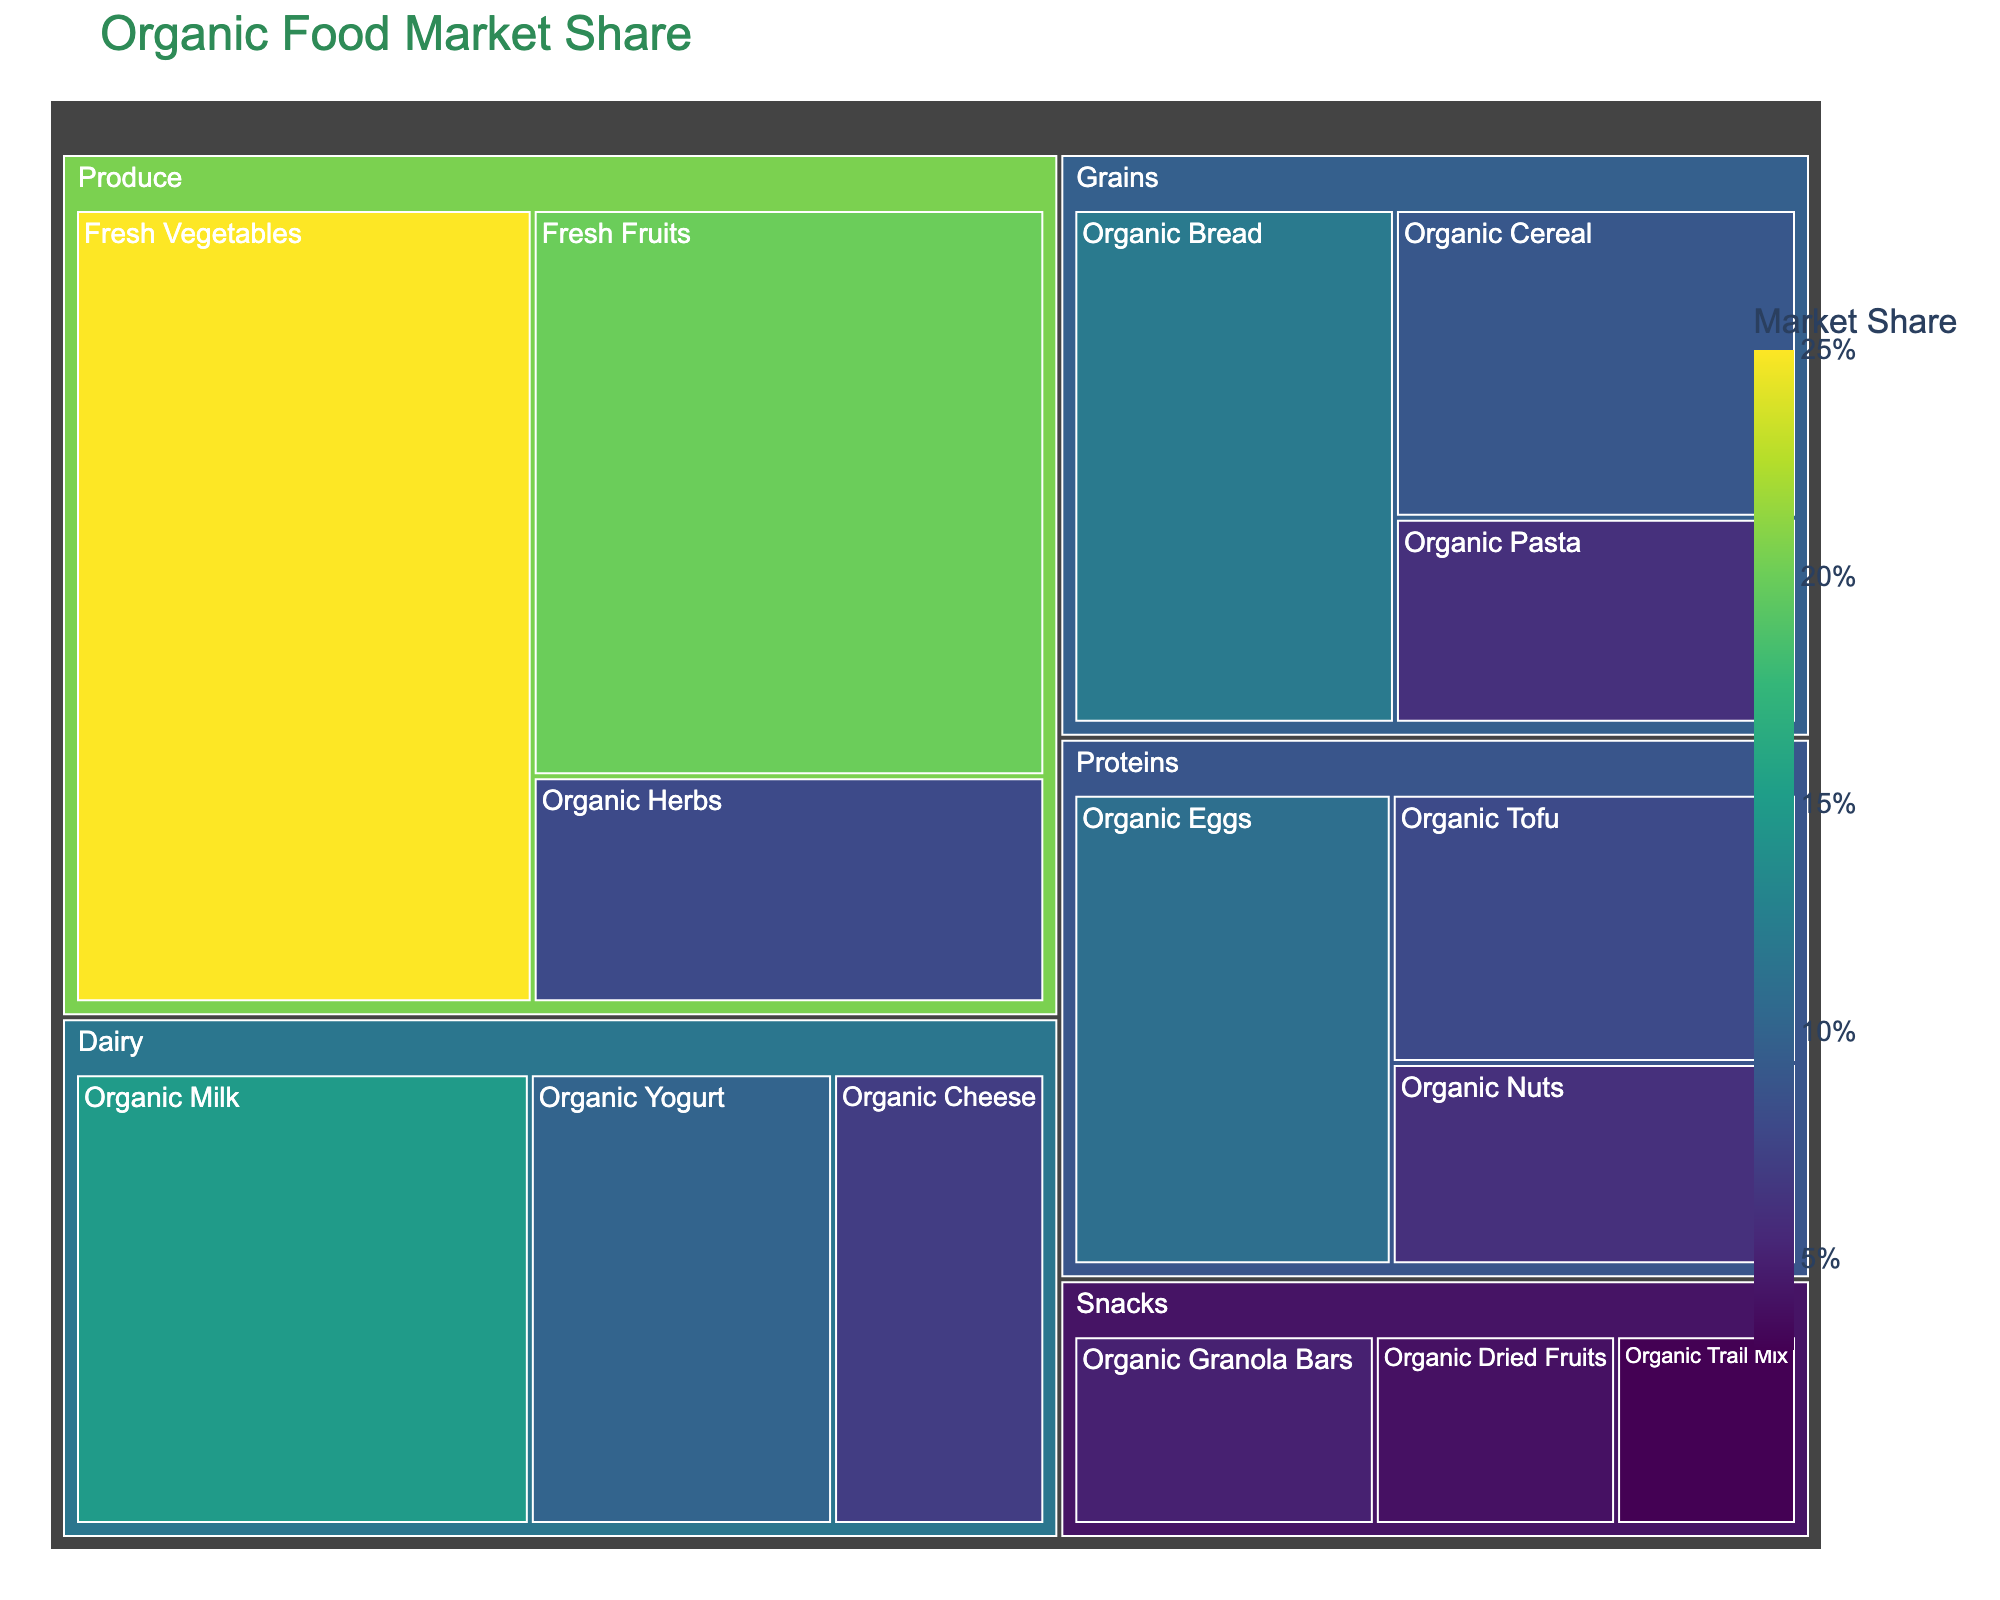What is the title of the treemap? The title of the treemap can be found at the top of the figure in a larger, bolder font size.
Answer: Organic Food Market Share How many categories are there in the treemap? The figure is divided into distinct sections with their own subcategories. Count these main divisions.
Answer: 5 Which category has the largest market share? Locate the largest section of the treemap, as the size represents market share.
Answer: Produce What is the combined market share of Fresh Vegetables and Fresh Fruits? Identify Fresh Vegetables and Fresh Fruits in the Produce category, then sum their values (25 + 20).
Answer: 45% Which category has the smallest market share? Locate the smallest section of the treemap.
Answer: Snacks How does the market share of Organic Herbs compare to Organic Cheese? Find both subcategories and compare their values (Organic Herbs: 8, Organic Cheese: 7).
Answer: Organic Herbs What is the difference in market share between Organic Milk and Organic Yogurt? Subtract the smaller value from the larger one (15 - 10 = 5).
Answer: 5% What is the average market share of the subcategories in the Dairy category? Sum the values of Organic Milk, Organic Yogurt, and Organic Cheese, then divide by 3 ((15 + 10 + 7) / 3 = 10.67).
Answer: 10.67% Which category has a higher market share, Organic Bread or Organic Eggs? Compare the values of both subcategories (Organic Bread: 12, Organic Eggs: 11).
Answer: Organic Bread What's the total market share of all categories combined? Sum the values of all subcategories: (25 + 20 + 8 + 15 + 10 + 7 + 12 + 9 + 6 + 11 + 8 + 6 + 5 + 4 + 3 = 149).
Answer: 149% 